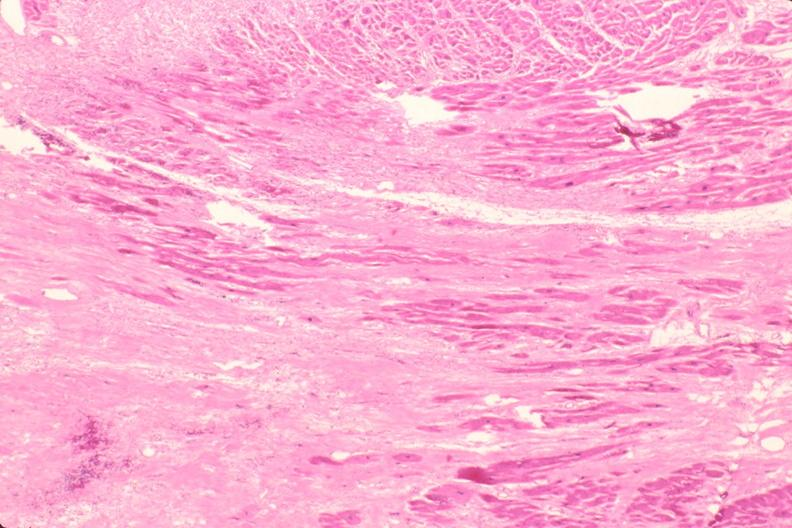what is present?
Answer the question using a single word or phrase. Cardiovascular 